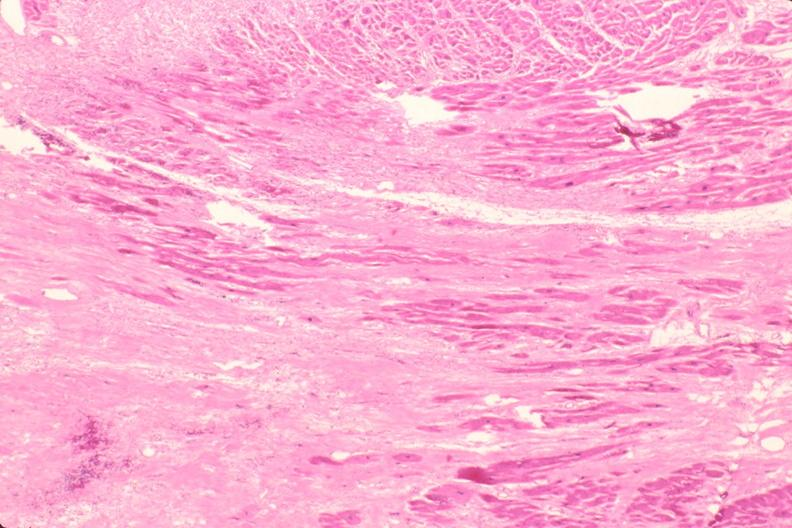what is present?
Answer the question using a single word or phrase. Cardiovascular 